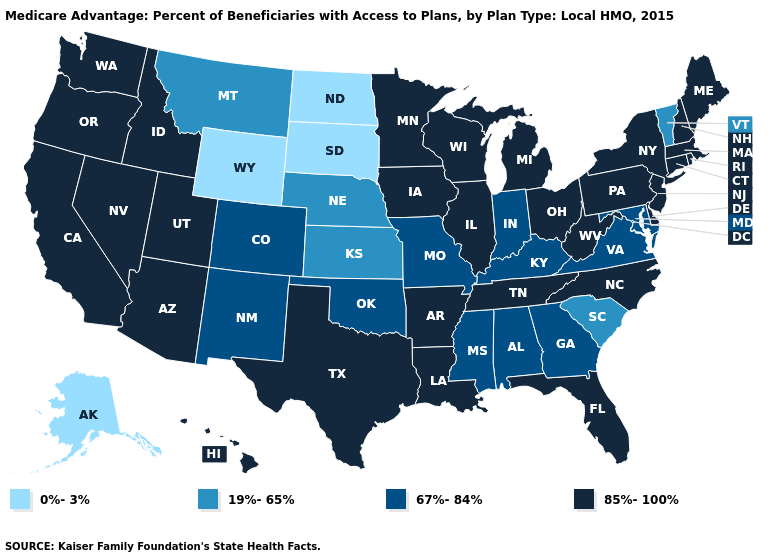What is the value of Ohio?
Concise answer only. 85%-100%. Which states have the lowest value in the Northeast?
Answer briefly. Vermont. Among the states that border Maryland , which have the highest value?
Quick response, please. Delaware, Pennsylvania, West Virginia. Name the states that have a value in the range 67%-84%?
Concise answer only. Colorado, Georgia, Indiana, Kentucky, Maryland, Missouri, Mississippi, New Mexico, Oklahoma, Virginia, Alabama. Does North Dakota have the highest value in the USA?
Keep it brief. No. What is the value of Pennsylvania?
Short answer required. 85%-100%. Which states have the lowest value in the West?
Write a very short answer. Alaska, Wyoming. Does Minnesota have the highest value in the USA?
Give a very brief answer. Yes. What is the value of Nevada?
Write a very short answer. 85%-100%. Name the states that have a value in the range 85%-100%?
Give a very brief answer. California, Connecticut, Delaware, Florida, Hawaii, Iowa, Idaho, Illinois, Louisiana, Massachusetts, Maine, Michigan, Minnesota, North Carolina, New Hampshire, New Jersey, Nevada, New York, Ohio, Oregon, Pennsylvania, Rhode Island, Tennessee, Texas, Utah, Washington, Wisconsin, West Virginia, Arkansas, Arizona. Does the map have missing data?
Answer briefly. No. What is the lowest value in the USA?
Short answer required. 0%-3%. What is the value of Georgia?
Keep it brief. 67%-84%. Which states have the lowest value in the Northeast?
Be succinct. Vermont. Does New York have the highest value in the Northeast?
Concise answer only. Yes. 